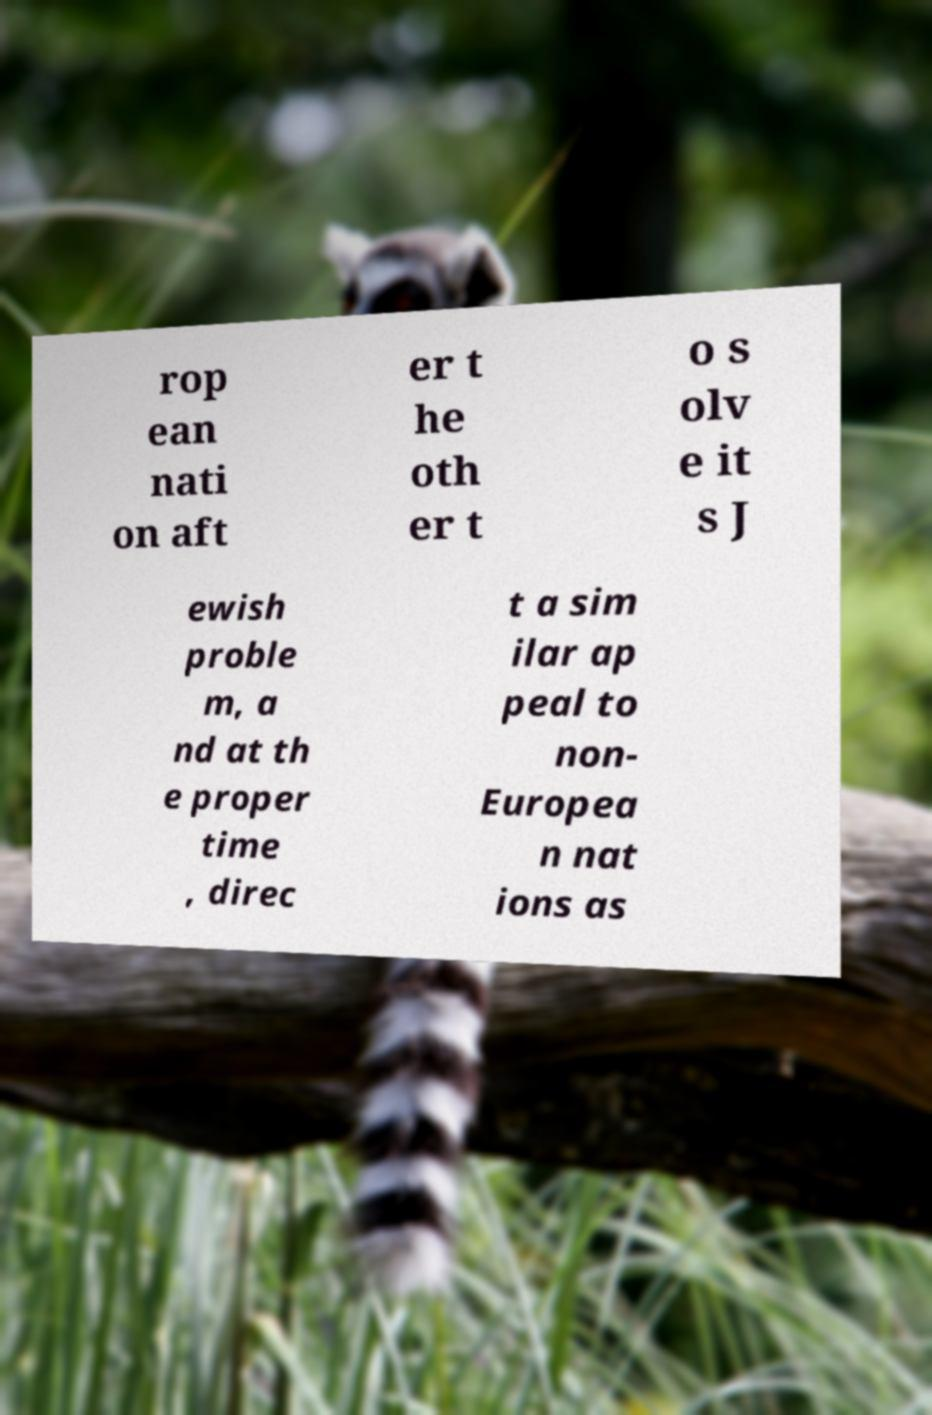For documentation purposes, I need the text within this image transcribed. Could you provide that? rop ean nati on aft er t he oth er t o s olv e it s J ewish proble m, a nd at th e proper time , direc t a sim ilar ap peal to non- Europea n nat ions as 